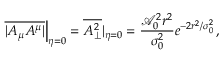Convert formula to latex. <formula><loc_0><loc_0><loc_500><loc_500>\overline { { | A _ { \mu } A ^ { \mu } | } } \right | _ { \eta = 0 } = \overline { { A _ { \perp } ^ { 2 } } } | _ { \eta = 0 } = \frac { \mathcal { A } _ { 0 } ^ { 2 } r ^ { 2 } } { \sigma _ { 0 } ^ { 2 } } e ^ { - 2 r ^ { 2 } / \sigma _ { 0 } ^ { 2 } } \, ,</formula> 